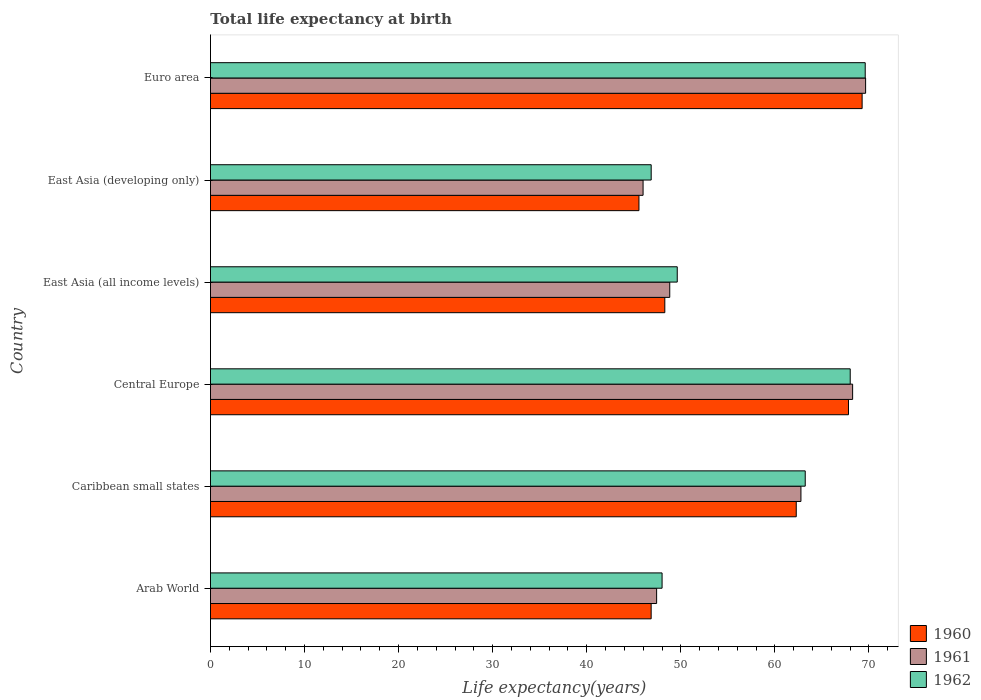How many different coloured bars are there?
Provide a short and direct response. 3. How many groups of bars are there?
Provide a succinct answer. 6. What is the label of the 3rd group of bars from the top?
Offer a terse response. East Asia (all income levels). What is the life expectancy at birth in in 1962 in East Asia (developing only)?
Offer a terse response. 46.85. Across all countries, what is the maximum life expectancy at birth in in 1960?
Your answer should be compact. 69.27. Across all countries, what is the minimum life expectancy at birth in in 1962?
Give a very brief answer. 46.85. In which country was the life expectancy at birth in in 1962 maximum?
Offer a terse response. Euro area. In which country was the life expectancy at birth in in 1961 minimum?
Give a very brief answer. East Asia (developing only). What is the total life expectancy at birth in in 1962 in the graph?
Offer a very short reply. 345.31. What is the difference between the life expectancy at birth in in 1960 in Arab World and that in Euro area?
Your answer should be very brief. -22.43. What is the difference between the life expectancy at birth in in 1962 in East Asia (all income levels) and the life expectancy at birth in in 1960 in Central Europe?
Make the answer very short. -18.2. What is the average life expectancy at birth in in 1962 per country?
Give a very brief answer. 57.55. What is the difference between the life expectancy at birth in in 1961 and life expectancy at birth in in 1962 in Central Europe?
Offer a very short reply. 0.26. In how many countries, is the life expectancy at birth in in 1961 greater than 4 years?
Give a very brief answer. 6. What is the ratio of the life expectancy at birth in in 1961 in Central Europe to that in East Asia (all income levels)?
Offer a terse response. 1.4. What is the difference between the highest and the second highest life expectancy at birth in in 1961?
Make the answer very short. 1.38. What is the difference between the highest and the lowest life expectancy at birth in in 1961?
Offer a very short reply. 23.66. In how many countries, is the life expectancy at birth in in 1961 greater than the average life expectancy at birth in in 1961 taken over all countries?
Your answer should be very brief. 3. What does the 1st bar from the top in Central Europe represents?
Ensure brevity in your answer.  1962. What does the 1st bar from the bottom in Central Europe represents?
Keep it short and to the point. 1960. Is it the case that in every country, the sum of the life expectancy at birth in in 1962 and life expectancy at birth in in 1960 is greater than the life expectancy at birth in in 1961?
Ensure brevity in your answer.  Yes. What is the difference between two consecutive major ticks on the X-axis?
Provide a succinct answer. 10. Are the values on the major ticks of X-axis written in scientific E-notation?
Offer a terse response. No. How are the legend labels stacked?
Provide a succinct answer. Vertical. What is the title of the graph?
Provide a short and direct response. Total life expectancy at birth. What is the label or title of the X-axis?
Your response must be concise. Life expectancy(years). What is the Life expectancy(years) of 1960 in Arab World?
Offer a very short reply. 46.85. What is the Life expectancy(years) in 1961 in Arab World?
Offer a terse response. 47.43. What is the Life expectancy(years) of 1962 in Arab World?
Provide a succinct answer. 48.01. What is the Life expectancy(years) in 1960 in Caribbean small states?
Make the answer very short. 62.27. What is the Life expectancy(years) in 1961 in Caribbean small states?
Your response must be concise. 62.77. What is the Life expectancy(years) in 1962 in Caribbean small states?
Offer a very short reply. 63.23. What is the Life expectancy(years) in 1960 in Central Europe?
Your answer should be compact. 67.82. What is the Life expectancy(years) in 1961 in Central Europe?
Make the answer very short. 68.26. What is the Life expectancy(years) in 1962 in Central Europe?
Make the answer very short. 68.01. What is the Life expectancy(years) in 1960 in East Asia (all income levels)?
Keep it short and to the point. 48.3. What is the Life expectancy(years) in 1961 in East Asia (all income levels)?
Your response must be concise. 48.82. What is the Life expectancy(years) of 1962 in East Asia (all income levels)?
Provide a short and direct response. 49.62. What is the Life expectancy(years) in 1960 in East Asia (developing only)?
Give a very brief answer. 45.55. What is the Life expectancy(years) in 1961 in East Asia (developing only)?
Make the answer very short. 45.99. What is the Life expectancy(years) in 1962 in East Asia (developing only)?
Keep it short and to the point. 46.85. What is the Life expectancy(years) in 1960 in Euro area?
Provide a short and direct response. 69.27. What is the Life expectancy(years) of 1961 in Euro area?
Your answer should be very brief. 69.64. What is the Life expectancy(years) of 1962 in Euro area?
Offer a very short reply. 69.6. Across all countries, what is the maximum Life expectancy(years) in 1960?
Offer a very short reply. 69.27. Across all countries, what is the maximum Life expectancy(years) in 1961?
Provide a short and direct response. 69.64. Across all countries, what is the maximum Life expectancy(years) of 1962?
Give a very brief answer. 69.6. Across all countries, what is the minimum Life expectancy(years) in 1960?
Your answer should be very brief. 45.55. Across all countries, what is the minimum Life expectancy(years) of 1961?
Provide a succinct answer. 45.99. Across all countries, what is the minimum Life expectancy(years) in 1962?
Keep it short and to the point. 46.85. What is the total Life expectancy(years) of 1960 in the graph?
Your answer should be compact. 340.06. What is the total Life expectancy(years) in 1961 in the graph?
Give a very brief answer. 342.92. What is the total Life expectancy(years) of 1962 in the graph?
Offer a very short reply. 345.31. What is the difference between the Life expectancy(years) in 1960 in Arab World and that in Caribbean small states?
Your answer should be very brief. -15.42. What is the difference between the Life expectancy(years) in 1961 in Arab World and that in Caribbean small states?
Offer a terse response. -15.34. What is the difference between the Life expectancy(years) of 1962 in Arab World and that in Caribbean small states?
Your answer should be compact. -15.22. What is the difference between the Life expectancy(years) of 1960 in Arab World and that in Central Europe?
Keep it short and to the point. -20.98. What is the difference between the Life expectancy(years) in 1961 in Arab World and that in Central Europe?
Your answer should be compact. -20.84. What is the difference between the Life expectancy(years) in 1962 in Arab World and that in Central Europe?
Provide a succinct answer. -20. What is the difference between the Life expectancy(years) of 1960 in Arab World and that in East Asia (all income levels)?
Give a very brief answer. -1.45. What is the difference between the Life expectancy(years) of 1961 in Arab World and that in East Asia (all income levels)?
Offer a terse response. -1.4. What is the difference between the Life expectancy(years) in 1962 in Arab World and that in East Asia (all income levels)?
Give a very brief answer. -1.61. What is the difference between the Life expectancy(years) of 1960 in Arab World and that in East Asia (developing only)?
Your answer should be compact. 1.3. What is the difference between the Life expectancy(years) of 1961 in Arab World and that in East Asia (developing only)?
Your response must be concise. 1.44. What is the difference between the Life expectancy(years) in 1962 in Arab World and that in East Asia (developing only)?
Give a very brief answer. 1.16. What is the difference between the Life expectancy(years) in 1960 in Arab World and that in Euro area?
Give a very brief answer. -22.43. What is the difference between the Life expectancy(years) in 1961 in Arab World and that in Euro area?
Give a very brief answer. -22.22. What is the difference between the Life expectancy(years) of 1962 in Arab World and that in Euro area?
Your response must be concise. -21.6. What is the difference between the Life expectancy(years) in 1960 in Caribbean small states and that in Central Europe?
Offer a terse response. -5.55. What is the difference between the Life expectancy(years) in 1961 in Caribbean small states and that in Central Europe?
Provide a succinct answer. -5.49. What is the difference between the Life expectancy(years) in 1962 in Caribbean small states and that in Central Europe?
Provide a short and direct response. -4.78. What is the difference between the Life expectancy(years) in 1960 in Caribbean small states and that in East Asia (all income levels)?
Your answer should be compact. 13.97. What is the difference between the Life expectancy(years) in 1961 in Caribbean small states and that in East Asia (all income levels)?
Give a very brief answer. 13.95. What is the difference between the Life expectancy(years) of 1962 in Caribbean small states and that in East Asia (all income levels)?
Offer a terse response. 13.61. What is the difference between the Life expectancy(years) in 1960 in Caribbean small states and that in East Asia (developing only)?
Give a very brief answer. 16.72. What is the difference between the Life expectancy(years) in 1961 in Caribbean small states and that in East Asia (developing only)?
Ensure brevity in your answer.  16.78. What is the difference between the Life expectancy(years) in 1962 in Caribbean small states and that in East Asia (developing only)?
Provide a short and direct response. 16.37. What is the difference between the Life expectancy(years) in 1960 in Caribbean small states and that in Euro area?
Ensure brevity in your answer.  -7. What is the difference between the Life expectancy(years) of 1961 in Caribbean small states and that in Euro area?
Provide a succinct answer. -6.88. What is the difference between the Life expectancy(years) of 1962 in Caribbean small states and that in Euro area?
Provide a succinct answer. -6.38. What is the difference between the Life expectancy(years) of 1960 in Central Europe and that in East Asia (all income levels)?
Provide a succinct answer. 19.53. What is the difference between the Life expectancy(years) of 1961 in Central Europe and that in East Asia (all income levels)?
Your answer should be very brief. 19.44. What is the difference between the Life expectancy(years) of 1962 in Central Europe and that in East Asia (all income levels)?
Your response must be concise. 18.39. What is the difference between the Life expectancy(years) in 1960 in Central Europe and that in East Asia (developing only)?
Provide a succinct answer. 22.27. What is the difference between the Life expectancy(years) of 1961 in Central Europe and that in East Asia (developing only)?
Ensure brevity in your answer.  22.28. What is the difference between the Life expectancy(years) of 1962 in Central Europe and that in East Asia (developing only)?
Provide a succinct answer. 21.16. What is the difference between the Life expectancy(years) of 1960 in Central Europe and that in Euro area?
Your answer should be very brief. -1.45. What is the difference between the Life expectancy(years) of 1961 in Central Europe and that in Euro area?
Provide a short and direct response. -1.38. What is the difference between the Life expectancy(years) of 1962 in Central Europe and that in Euro area?
Offer a very short reply. -1.59. What is the difference between the Life expectancy(years) in 1960 in East Asia (all income levels) and that in East Asia (developing only)?
Ensure brevity in your answer.  2.75. What is the difference between the Life expectancy(years) of 1961 in East Asia (all income levels) and that in East Asia (developing only)?
Provide a succinct answer. 2.84. What is the difference between the Life expectancy(years) in 1962 in East Asia (all income levels) and that in East Asia (developing only)?
Offer a very short reply. 2.77. What is the difference between the Life expectancy(years) of 1960 in East Asia (all income levels) and that in Euro area?
Your answer should be very brief. -20.98. What is the difference between the Life expectancy(years) of 1961 in East Asia (all income levels) and that in Euro area?
Keep it short and to the point. -20.82. What is the difference between the Life expectancy(years) of 1962 in East Asia (all income levels) and that in Euro area?
Keep it short and to the point. -19.98. What is the difference between the Life expectancy(years) of 1960 in East Asia (developing only) and that in Euro area?
Ensure brevity in your answer.  -23.72. What is the difference between the Life expectancy(years) of 1961 in East Asia (developing only) and that in Euro area?
Offer a terse response. -23.66. What is the difference between the Life expectancy(years) of 1962 in East Asia (developing only) and that in Euro area?
Offer a very short reply. -22.75. What is the difference between the Life expectancy(years) in 1960 in Arab World and the Life expectancy(years) in 1961 in Caribbean small states?
Give a very brief answer. -15.92. What is the difference between the Life expectancy(years) in 1960 in Arab World and the Life expectancy(years) in 1962 in Caribbean small states?
Offer a very short reply. -16.38. What is the difference between the Life expectancy(years) of 1961 in Arab World and the Life expectancy(years) of 1962 in Caribbean small states?
Make the answer very short. -15.8. What is the difference between the Life expectancy(years) of 1960 in Arab World and the Life expectancy(years) of 1961 in Central Europe?
Make the answer very short. -21.42. What is the difference between the Life expectancy(years) of 1960 in Arab World and the Life expectancy(years) of 1962 in Central Europe?
Make the answer very short. -21.16. What is the difference between the Life expectancy(years) in 1961 in Arab World and the Life expectancy(years) in 1962 in Central Europe?
Provide a short and direct response. -20.58. What is the difference between the Life expectancy(years) in 1960 in Arab World and the Life expectancy(years) in 1961 in East Asia (all income levels)?
Provide a short and direct response. -1.98. What is the difference between the Life expectancy(years) of 1960 in Arab World and the Life expectancy(years) of 1962 in East Asia (all income levels)?
Your answer should be very brief. -2.77. What is the difference between the Life expectancy(years) of 1961 in Arab World and the Life expectancy(years) of 1962 in East Asia (all income levels)?
Make the answer very short. -2.19. What is the difference between the Life expectancy(years) in 1960 in Arab World and the Life expectancy(years) in 1961 in East Asia (developing only)?
Keep it short and to the point. 0.86. What is the difference between the Life expectancy(years) of 1960 in Arab World and the Life expectancy(years) of 1962 in East Asia (developing only)?
Ensure brevity in your answer.  -0. What is the difference between the Life expectancy(years) of 1961 in Arab World and the Life expectancy(years) of 1962 in East Asia (developing only)?
Provide a succinct answer. 0.58. What is the difference between the Life expectancy(years) in 1960 in Arab World and the Life expectancy(years) in 1961 in Euro area?
Ensure brevity in your answer.  -22.8. What is the difference between the Life expectancy(years) of 1960 in Arab World and the Life expectancy(years) of 1962 in Euro area?
Your answer should be very brief. -22.76. What is the difference between the Life expectancy(years) of 1961 in Arab World and the Life expectancy(years) of 1962 in Euro area?
Your response must be concise. -22.18. What is the difference between the Life expectancy(years) of 1960 in Caribbean small states and the Life expectancy(years) of 1961 in Central Europe?
Offer a very short reply. -5.99. What is the difference between the Life expectancy(years) of 1960 in Caribbean small states and the Life expectancy(years) of 1962 in Central Europe?
Provide a succinct answer. -5.74. What is the difference between the Life expectancy(years) of 1961 in Caribbean small states and the Life expectancy(years) of 1962 in Central Europe?
Offer a terse response. -5.24. What is the difference between the Life expectancy(years) of 1960 in Caribbean small states and the Life expectancy(years) of 1961 in East Asia (all income levels)?
Offer a terse response. 13.45. What is the difference between the Life expectancy(years) in 1960 in Caribbean small states and the Life expectancy(years) in 1962 in East Asia (all income levels)?
Keep it short and to the point. 12.65. What is the difference between the Life expectancy(years) in 1961 in Caribbean small states and the Life expectancy(years) in 1962 in East Asia (all income levels)?
Your answer should be compact. 13.15. What is the difference between the Life expectancy(years) of 1960 in Caribbean small states and the Life expectancy(years) of 1961 in East Asia (developing only)?
Your response must be concise. 16.28. What is the difference between the Life expectancy(years) of 1960 in Caribbean small states and the Life expectancy(years) of 1962 in East Asia (developing only)?
Your answer should be compact. 15.42. What is the difference between the Life expectancy(years) in 1961 in Caribbean small states and the Life expectancy(years) in 1962 in East Asia (developing only)?
Keep it short and to the point. 15.92. What is the difference between the Life expectancy(years) in 1960 in Caribbean small states and the Life expectancy(years) in 1961 in Euro area?
Your answer should be very brief. -7.37. What is the difference between the Life expectancy(years) of 1960 in Caribbean small states and the Life expectancy(years) of 1962 in Euro area?
Provide a short and direct response. -7.33. What is the difference between the Life expectancy(years) in 1961 in Caribbean small states and the Life expectancy(years) in 1962 in Euro area?
Provide a short and direct response. -6.83. What is the difference between the Life expectancy(years) of 1960 in Central Europe and the Life expectancy(years) of 1961 in East Asia (all income levels)?
Give a very brief answer. 19. What is the difference between the Life expectancy(years) of 1960 in Central Europe and the Life expectancy(years) of 1962 in East Asia (all income levels)?
Keep it short and to the point. 18.2. What is the difference between the Life expectancy(years) in 1961 in Central Europe and the Life expectancy(years) in 1962 in East Asia (all income levels)?
Keep it short and to the point. 18.64. What is the difference between the Life expectancy(years) in 1960 in Central Europe and the Life expectancy(years) in 1961 in East Asia (developing only)?
Provide a short and direct response. 21.84. What is the difference between the Life expectancy(years) in 1960 in Central Europe and the Life expectancy(years) in 1962 in East Asia (developing only)?
Your response must be concise. 20.97. What is the difference between the Life expectancy(years) of 1961 in Central Europe and the Life expectancy(years) of 1962 in East Asia (developing only)?
Your answer should be compact. 21.41. What is the difference between the Life expectancy(years) of 1960 in Central Europe and the Life expectancy(years) of 1961 in Euro area?
Make the answer very short. -1.82. What is the difference between the Life expectancy(years) in 1960 in Central Europe and the Life expectancy(years) in 1962 in Euro area?
Ensure brevity in your answer.  -1.78. What is the difference between the Life expectancy(years) of 1961 in Central Europe and the Life expectancy(years) of 1962 in Euro area?
Offer a terse response. -1.34. What is the difference between the Life expectancy(years) of 1960 in East Asia (all income levels) and the Life expectancy(years) of 1961 in East Asia (developing only)?
Provide a short and direct response. 2.31. What is the difference between the Life expectancy(years) in 1960 in East Asia (all income levels) and the Life expectancy(years) in 1962 in East Asia (developing only)?
Offer a very short reply. 1.45. What is the difference between the Life expectancy(years) in 1961 in East Asia (all income levels) and the Life expectancy(years) in 1962 in East Asia (developing only)?
Offer a terse response. 1.97. What is the difference between the Life expectancy(years) in 1960 in East Asia (all income levels) and the Life expectancy(years) in 1961 in Euro area?
Offer a very short reply. -21.35. What is the difference between the Life expectancy(years) of 1960 in East Asia (all income levels) and the Life expectancy(years) of 1962 in Euro area?
Provide a short and direct response. -21.3. What is the difference between the Life expectancy(years) of 1961 in East Asia (all income levels) and the Life expectancy(years) of 1962 in Euro area?
Your response must be concise. -20.78. What is the difference between the Life expectancy(years) of 1960 in East Asia (developing only) and the Life expectancy(years) of 1961 in Euro area?
Your answer should be very brief. -24.09. What is the difference between the Life expectancy(years) in 1960 in East Asia (developing only) and the Life expectancy(years) in 1962 in Euro area?
Ensure brevity in your answer.  -24.05. What is the difference between the Life expectancy(years) of 1961 in East Asia (developing only) and the Life expectancy(years) of 1962 in Euro area?
Your answer should be compact. -23.62. What is the average Life expectancy(years) of 1960 per country?
Make the answer very short. 56.68. What is the average Life expectancy(years) in 1961 per country?
Offer a terse response. 57.15. What is the average Life expectancy(years) in 1962 per country?
Ensure brevity in your answer.  57.55. What is the difference between the Life expectancy(years) of 1960 and Life expectancy(years) of 1961 in Arab World?
Ensure brevity in your answer.  -0.58. What is the difference between the Life expectancy(years) in 1960 and Life expectancy(years) in 1962 in Arab World?
Your answer should be compact. -1.16. What is the difference between the Life expectancy(years) in 1961 and Life expectancy(years) in 1962 in Arab World?
Ensure brevity in your answer.  -0.58. What is the difference between the Life expectancy(years) of 1960 and Life expectancy(years) of 1961 in Caribbean small states?
Offer a terse response. -0.5. What is the difference between the Life expectancy(years) in 1960 and Life expectancy(years) in 1962 in Caribbean small states?
Your answer should be very brief. -0.95. What is the difference between the Life expectancy(years) in 1961 and Life expectancy(years) in 1962 in Caribbean small states?
Offer a very short reply. -0.46. What is the difference between the Life expectancy(years) in 1960 and Life expectancy(years) in 1961 in Central Europe?
Your answer should be compact. -0.44. What is the difference between the Life expectancy(years) in 1960 and Life expectancy(years) in 1962 in Central Europe?
Your answer should be compact. -0.18. What is the difference between the Life expectancy(years) in 1961 and Life expectancy(years) in 1962 in Central Europe?
Your answer should be very brief. 0.26. What is the difference between the Life expectancy(years) of 1960 and Life expectancy(years) of 1961 in East Asia (all income levels)?
Your answer should be compact. -0.53. What is the difference between the Life expectancy(years) of 1960 and Life expectancy(years) of 1962 in East Asia (all income levels)?
Provide a short and direct response. -1.32. What is the difference between the Life expectancy(years) of 1961 and Life expectancy(years) of 1962 in East Asia (all income levels)?
Make the answer very short. -0.8. What is the difference between the Life expectancy(years) in 1960 and Life expectancy(years) in 1961 in East Asia (developing only)?
Make the answer very short. -0.44. What is the difference between the Life expectancy(years) of 1960 and Life expectancy(years) of 1962 in East Asia (developing only)?
Give a very brief answer. -1.3. What is the difference between the Life expectancy(years) of 1961 and Life expectancy(years) of 1962 in East Asia (developing only)?
Provide a short and direct response. -0.86. What is the difference between the Life expectancy(years) of 1960 and Life expectancy(years) of 1961 in Euro area?
Make the answer very short. -0.37. What is the difference between the Life expectancy(years) in 1960 and Life expectancy(years) in 1962 in Euro area?
Provide a succinct answer. -0.33. What is the difference between the Life expectancy(years) in 1961 and Life expectancy(years) in 1962 in Euro area?
Provide a succinct answer. 0.04. What is the ratio of the Life expectancy(years) in 1960 in Arab World to that in Caribbean small states?
Offer a very short reply. 0.75. What is the ratio of the Life expectancy(years) in 1961 in Arab World to that in Caribbean small states?
Provide a short and direct response. 0.76. What is the ratio of the Life expectancy(years) in 1962 in Arab World to that in Caribbean small states?
Keep it short and to the point. 0.76. What is the ratio of the Life expectancy(years) in 1960 in Arab World to that in Central Europe?
Provide a succinct answer. 0.69. What is the ratio of the Life expectancy(years) of 1961 in Arab World to that in Central Europe?
Provide a short and direct response. 0.69. What is the ratio of the Life expectancy(years) of 1962 in Arab World to that in Central Europe?
Offer a terse response. 0.71. What is the ratio of the Life expectancy(years) in 1961 in Arab World to that in East Asia (all income levels)?
Your response must be concise. 0.97. What is the ratio of the Life expectancy(years) of 1962 in Arab World to that in East Asia (all income levels)?
Offer a very short reply. 0.97. What is the ratio of the Life expectancy(years) in 1960 in Arab World to that in East Asia (developing only)?
Your response must be concise. 1.03. What is the ratio of the Life expectancy(years) of 1961 in Arab World to that in East Asia (developing only)?
Provide a short and direct response. 1.03. What is the ratio of the Life expectancy(years) in 1962 in Arab World to that in East Asia (developing only)?
Ensure brevity in your answer.  1.02. What is the ratio of the Life expectancy(years) of 1960 in Arab World to that in Euro area?
Your answer should be very brief. 0.68. What is the ratio of the Life expectancy(years) in 1961 in Arab World to that in Euro area?
Your answer should be very brief. 0.68. What is the ratio of the Life expectancy(years) in 1962 in Arab World to that in Euro area?
Give a very brief answer. 0.69. What is the ratio of the Life expectancy(years) in 1960 in Caribbean small states to that in Central Europe?
Your answer should be very brief. 0.92. What is the ratio of the Life expectancy(years) in 1961 in Caribbean small states to that in Central Europe?
Ensure brevity in your answer.  0.92. What is the ratio of the Life expectancy(years) of 1962 in Caribbean small states to that in Central Europe?
Provide a succinct answer. 0.93. What is the ratio of the Life expectancy(years) in 1960 in Caribbean small states to that in East Asia (all income levels)?
Your answer should be very brief. 1.29. What is the ratio of the Life expectancy(years) of 1961 in Caribbean small states to that in East Asia (all income levels)?
Your answer should be compact. 1.29. What is the ratio of the Life expectancy(years) of 1962 in Caribbean small states to that in East Asia (all income levels)?
Make the answer very short. 1.27. What is the ratio of the Life expectancy(years) of 1960 in Caribbean small states to that in East Asia (developing only)?
Your answer should be very brief. 1.37. What is the ratio of the Life expectancy(years) in 1961 in Caribbean small states to that in East Asia (developing only)?
Provide a succinct answer. 1.36. What is the ratio of the Life expectancy(years) of 1962 in Caribbean small states to that in East Asia (developing only)?
Offer a terse response. 1.35. What is the ratio of the Life expectancy(years) in 1960 in Caribbean small states to that in Euro area?
Your response must be concise. 0.9. What is the ratio of the Life expectancy(years) of 1961 in Caribbean small states to that in Euro area?
Your response must be concise. 0.9. What is the ratio of the Life expectancy(years) of 1962 in Caribbean small states to that in Euro area?
Offer a terse response. 0.91. What is the ratio of the Life expectancy(years) of 1960 in Central Europe to that in East Asia (all income levels)?
Keep it short and to the point. 1.4. What is the ratio of the Life expectancy(years) of 1961 in Central Europe to that in East Asia (all income levels)?
Provide a short and direct response. 1.4. What is the ratio of the Life expectancy(years) in 1962 in Central Europe to that in East Asia (all income levels)?
Your answer should be very brief. 1.37. What is the ratio of the Life expectancy(years) in 1960 in Central Europe to that in East Asia (developing only)?
Keep it short and to the point. 1.49. What is the ratio of the Life expectancy(years) in 1961 in Central Europe to that in East Asia (developing only)?
Give a very brief answer. 1.48. What is the ratio of the Life expectancy(years) in 1962 in Central Europe to that in East Asia (developing only)?
Ensure brevity in your answer.  1.45. What is the ratio of the Life expectancy(years) in 1960 in Central Europe to that in Euro area?
Ensure brevity in your answer.  0.98. What is the ratio of the Life expectancy(years) of 1961 in Central Europe to that in Euro area?
Your answer should be very brief. 0.98. What is the ratio of the Life expectancy(years) in 1962 in Central Europe to that in Euro area?
Your response must be concise. 0.98. What is the ratio of the Life expectancy(years) of 1960 in East Asia (all income levels) to that in East Asia (developing only)?
Offer a very short reply. 1.06. What is the ratio of the Life expectancy(years) in 1961 in East Asia (all income levels) to that in East Asia (developing only)?
Keep it short and to the point. 1.06. What is the ratio of the Life expectancy(years) of 1962 in East Asia (all income levels) to that in East Asia (developing only)?
Keep it short and to the point. 1.06. What is the ratio of the Life expectancy(years) in 1960 in East Asia (all income levels) to that in Euro area?
Keep it short and to the point. 0.7. What is the ratio of the Life expectancy(years) of 1961 in East Asia (all income levels) to that in Euro area?
Provide a short and direct response. 0.7. What is the ratio of the Life expectancy(years) of 1962 in East Asia (all income levels) to that in Euro area?
Give a very brief answer. 0.71. What is the ratio of the Life expectancy(years) in 1960 in East Asia (developing only) to that in Euro area?
Make the answer very short. 0.66. What is the ratio of the Life expectancy(years) of 1961 in East Asia (developing only) to that in Euro area?
Your response must be concise. 0.66. What is the ratio of the Life expectancy(years) in 1962 in East Asia (developing only) to that in Euro area?
Your answer should be compact. 0.67. What is the difference between the highest and the second highest Life expectancy(years) in 1960?
Provide a succinct answer. 1.45. What is the difference between the highest and the second highest Life expectancy(years) of 1961?
Provide a short and direct response. 1.38. What is the difference between the highest and the second highest Life expectancy(years) in 1962?
Provide a succinct answer. 1.59. What is the difference between the highest and the lowest Life expectancy(years) of 1960?
Provide a short and direct response. 23.72. What is the difference between the highest and the lowest Life expectancy(years) in 1961?
Make the answer very short. 23.66. What is the difference between the highest and the lowest Life expectancy(years) of 1962?
Give a very brief answer. 22.75. 